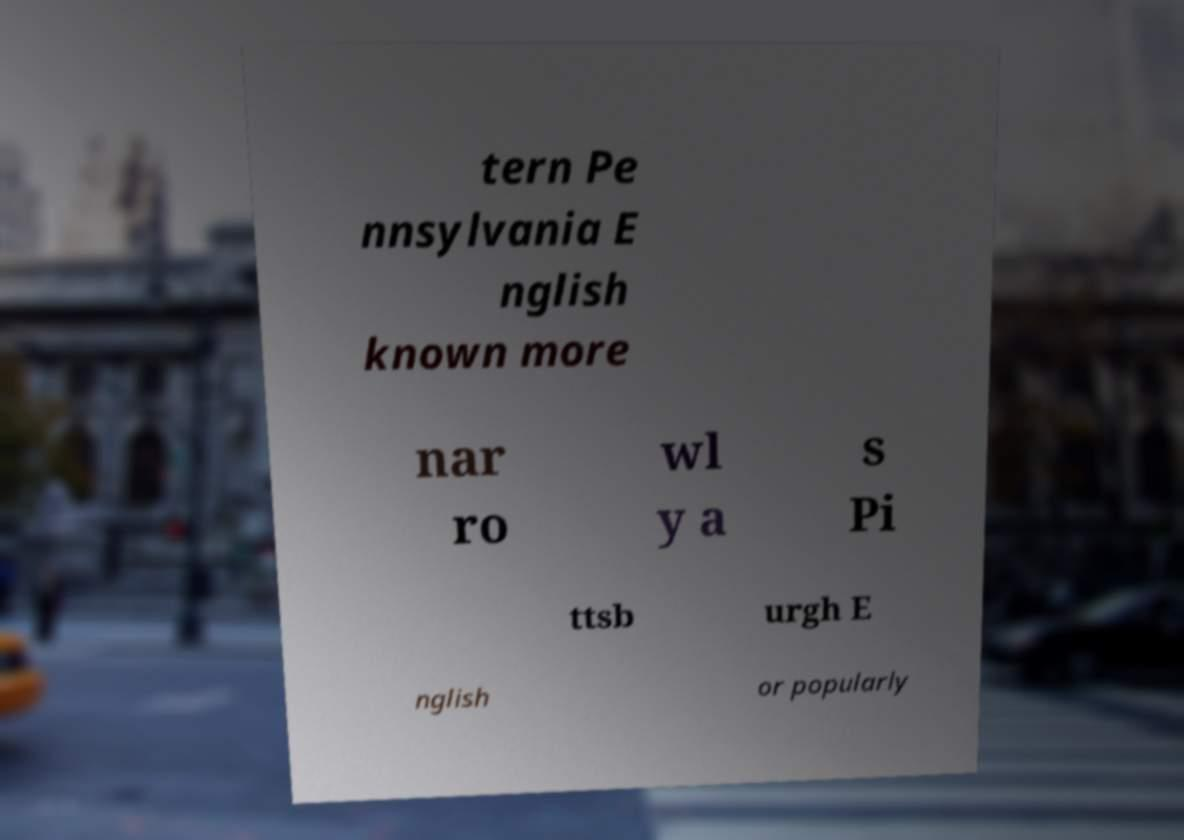Could you extract and type out the text from this image? tern Pe nnsylvania E nglish known more nar ro wl y a s Pi ttsb urgh E nglish or popularly 